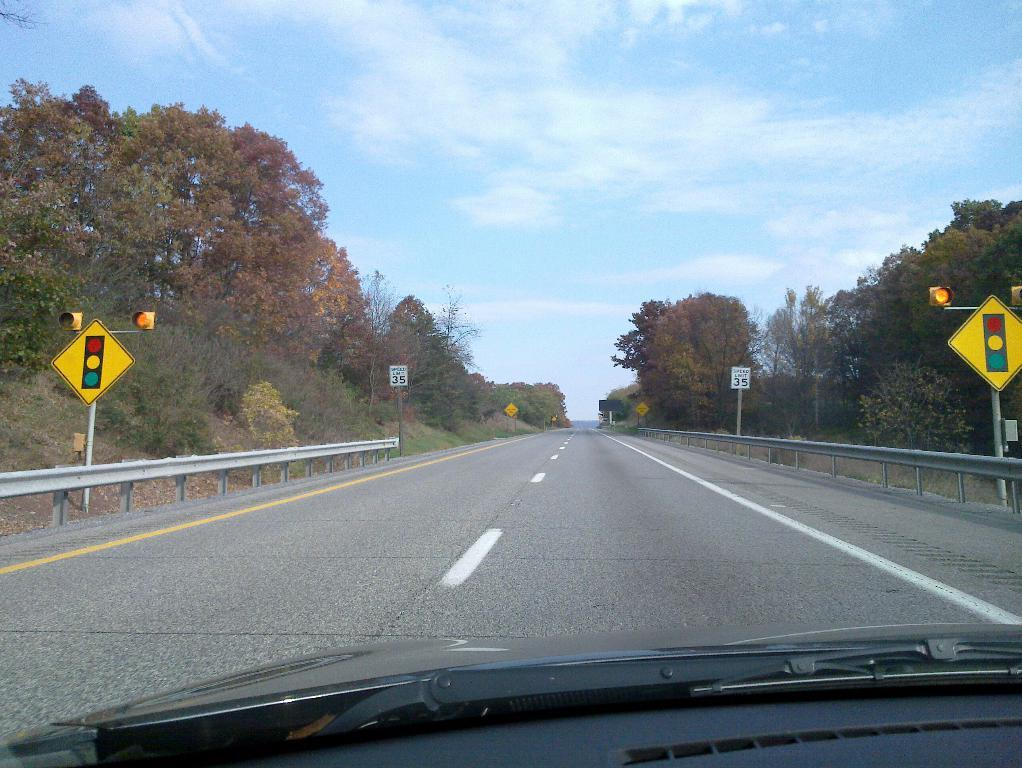What is the main subject of the image? There is a vehicle in the image. What is the setting of the image? There is a road in the image. What type of natural elements can be seen in the image? There are trees in the image. What structures are present beside the road? There are poles beside the road in the image. What shape is the crook in the image? There is no crook present in the image. How does the vehicle fall in the image? The vehicle does not fall in the image; it is stationary on the road. 